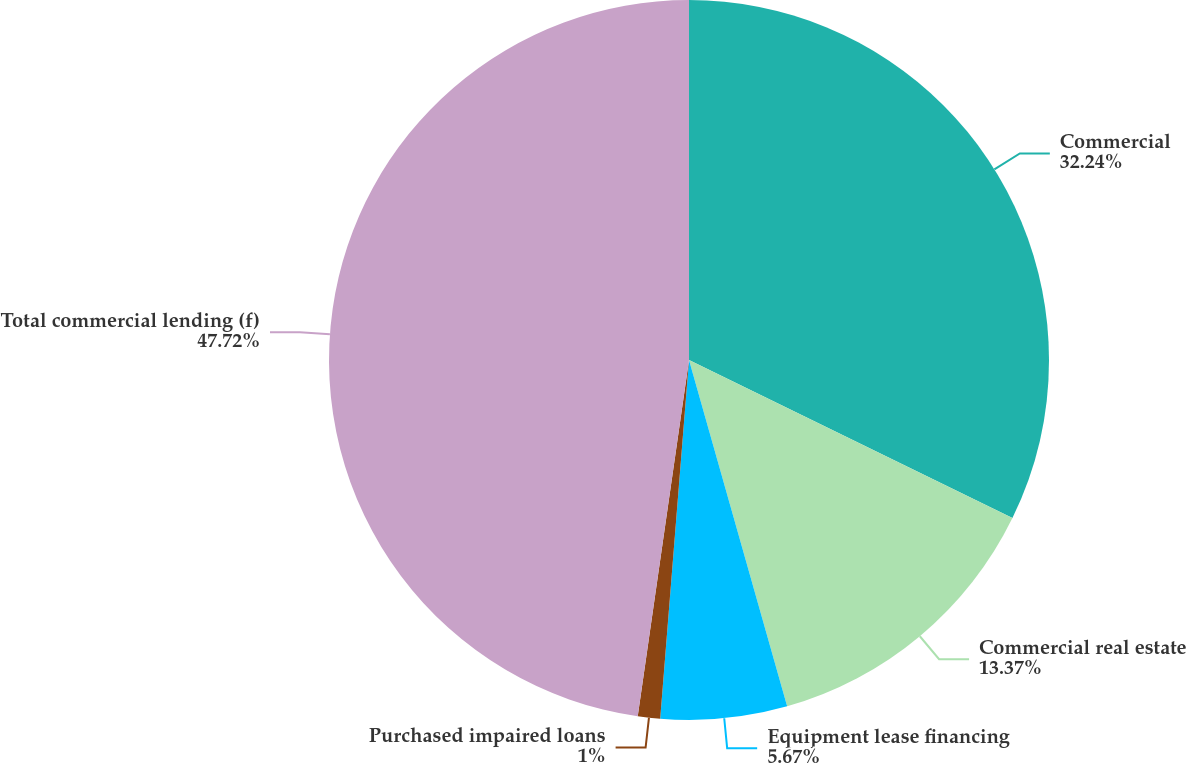Convert chart to OTSL. <chart><loc_0><loc_0><loc_500><loc_500><pie_chart><fcel>Commercial<fcel>Commercial real estate<fcel>Equipment lease financing<fcel>Purchased impaired loans<fcel>Total commercial lending (f)<nl><fcel>32.24%<fcel>13.37%<fcel>5.67%<fcel>1.0%<fcel>47.73%<nl></chart> 